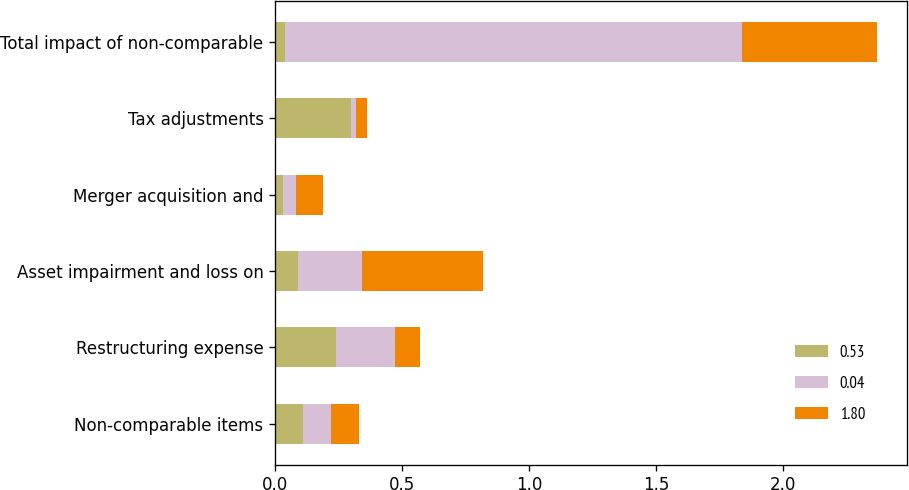<chart> <loc_0><loc_0><loc_500><loc_500><stacked_bar_chart><ecel><fcel>Non-comparable items<fcel>Restructuring expense<fcel>Asset impairment and loss on<fcel>Merger acquisition and<fcel>Tax adjustments<fcel>Total impact of non-comparable<nl><fcel>0.53<fcel>0.11<fcel>0.24<fcel>0.09<fcel>0.03<fcel>0.3<fcel>0.04<nl><fcel>0.04<fcel>0.11<fcel>0.23<fcel>0.25<fcel>0.05<fcel>0.02<fcel>1.8<nl><fcel>1.8<fcel>0.11<fcel>0.1<fcel>0.48<fcel>0.11<fcel>0.04<fcel>0.53<nl></chart> 